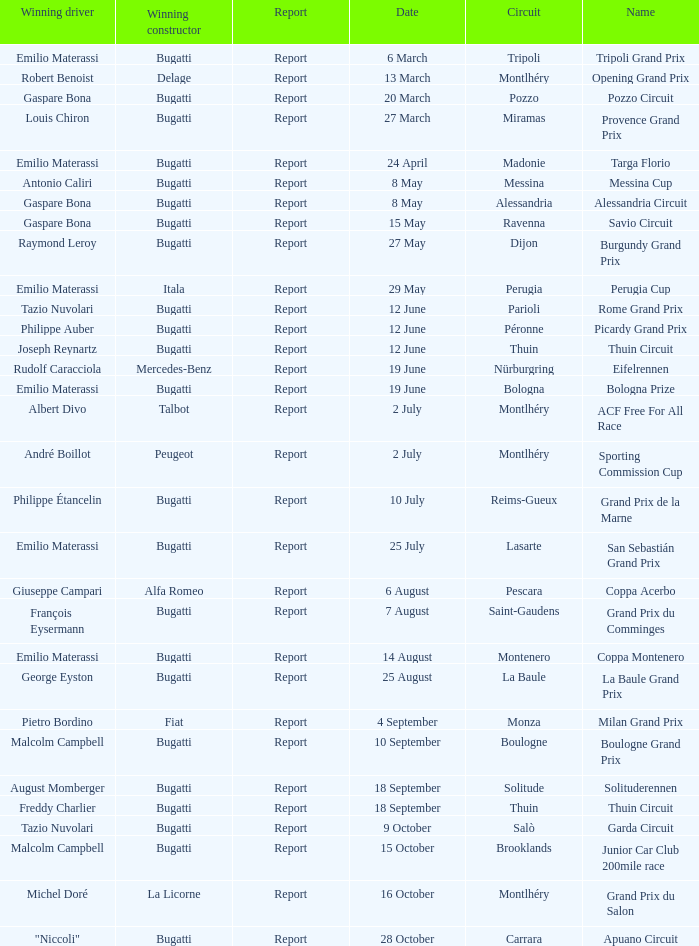Who was the winning constructor at the circuit of parioli? Bugatti. 